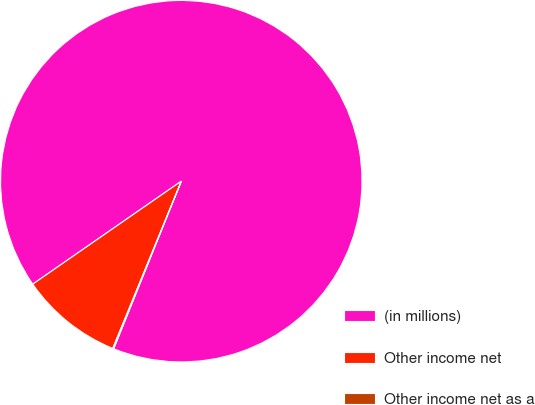Convert chart. <chart><loc_0><loc_0><loc_500><loc_500><pie_chart><fcel>(in millions)<fcel>Other income net<fcel>Other income net as a<nl><fcel>90.75%<fcel>9.16%<fcel>0.09%<nl></chart> 